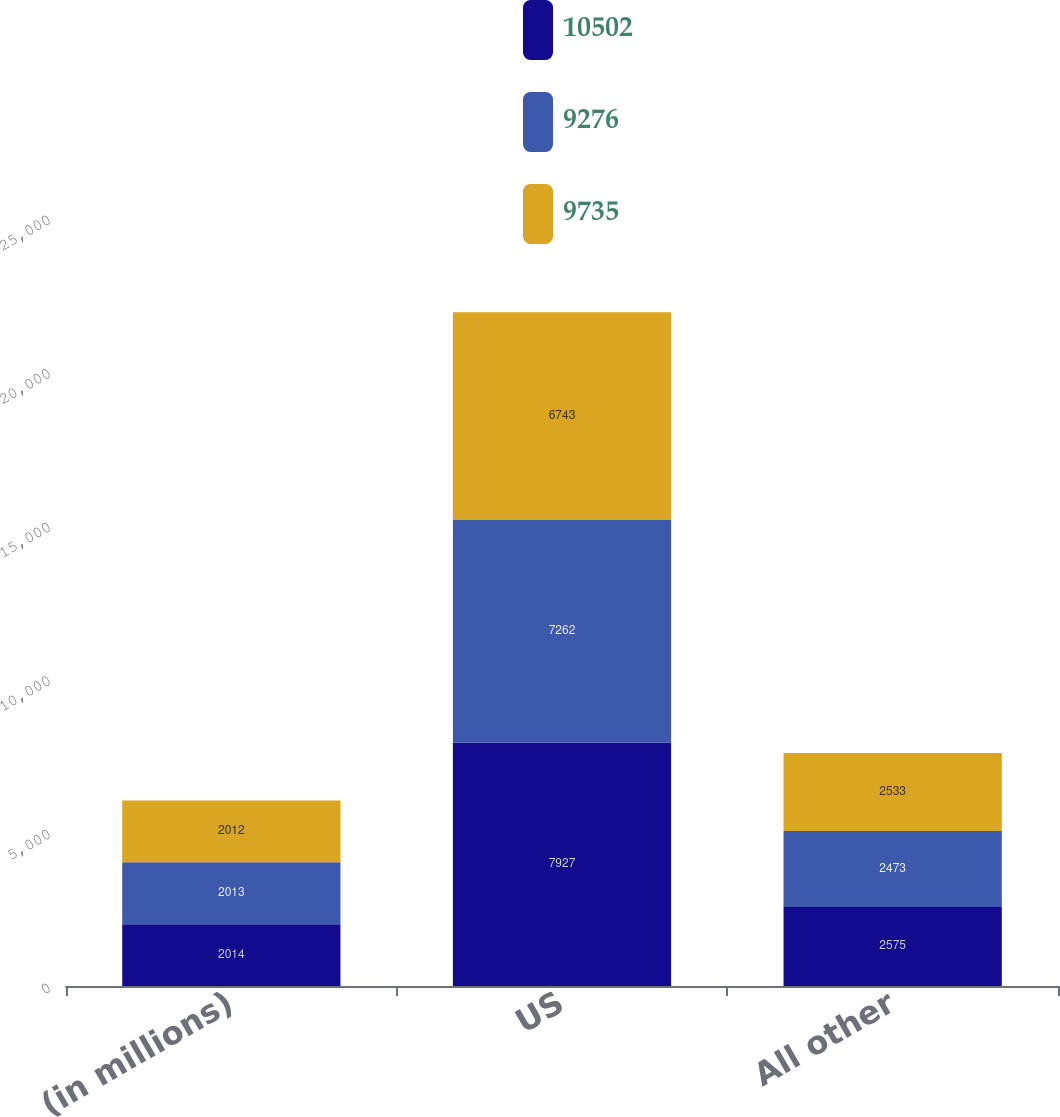<chart> <loc_0><loc_0><loc_500><loc_500><stacked_bar_chart><ecel><fcel>(in millions)<fcel>US<fcel>All other<nl><fcel>10502<fcel>2014<fcel>7927<fcel>2575<nl><fcel>9276<fcel>2013<fcel>7262<fcel>2473<nl><fcel>9735<fcel>2012<fcel>6743<fcel>2533<nl></chart> 